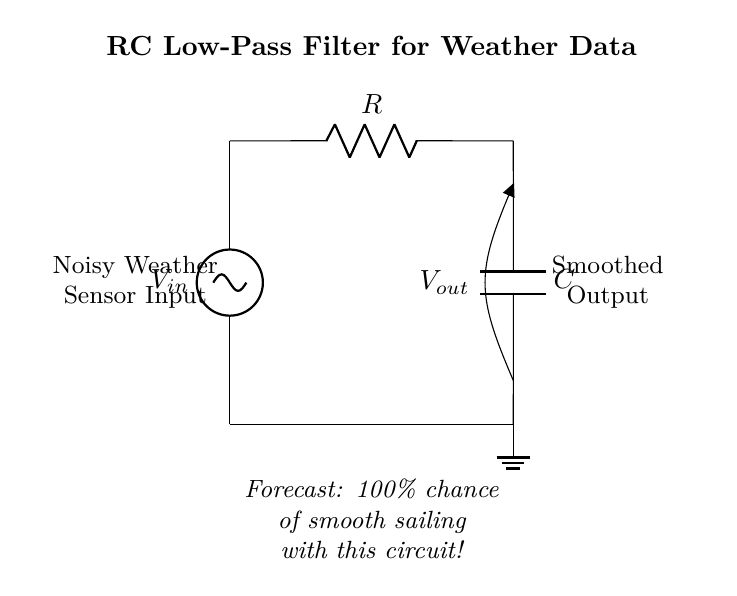What is the input component in this circuit? The input component is a voltage source labeled as V in, which represents the noisy weather sensor data coming into the circuit.
Answer: Voltage source What type of filter is represented by this circuit? This circuit is an RC low-pass filter, which is designed to allow low-frequency signals to pass while attenuating higher-frequency noise.
Answer: Low-pass filter What is the role of the resistor in this circuit? The resistor in this circuit limits the current flow and, along with the capacitor, it defines the cutoff frequency of the filter.
Answer: Limit current What is the output voltage of this circuit labeled as? The output voltage is labeled as V out, which represents the smoothed output data after filtering the input.
Answer: V out How does the capacitor affect the signal in this circuit? The capacitor smooths the signal by charging and discharging, which helps to filter out rapid fluctuations (high-frequency noise) from the sensor data.
Answer: Smooths signal Which two components are connected in series before ground in this circuit? The resistor and capacitor are connected in series before the ground, forming the key part of the RC low-pass filter.
Answer: Resistor and capacitor 